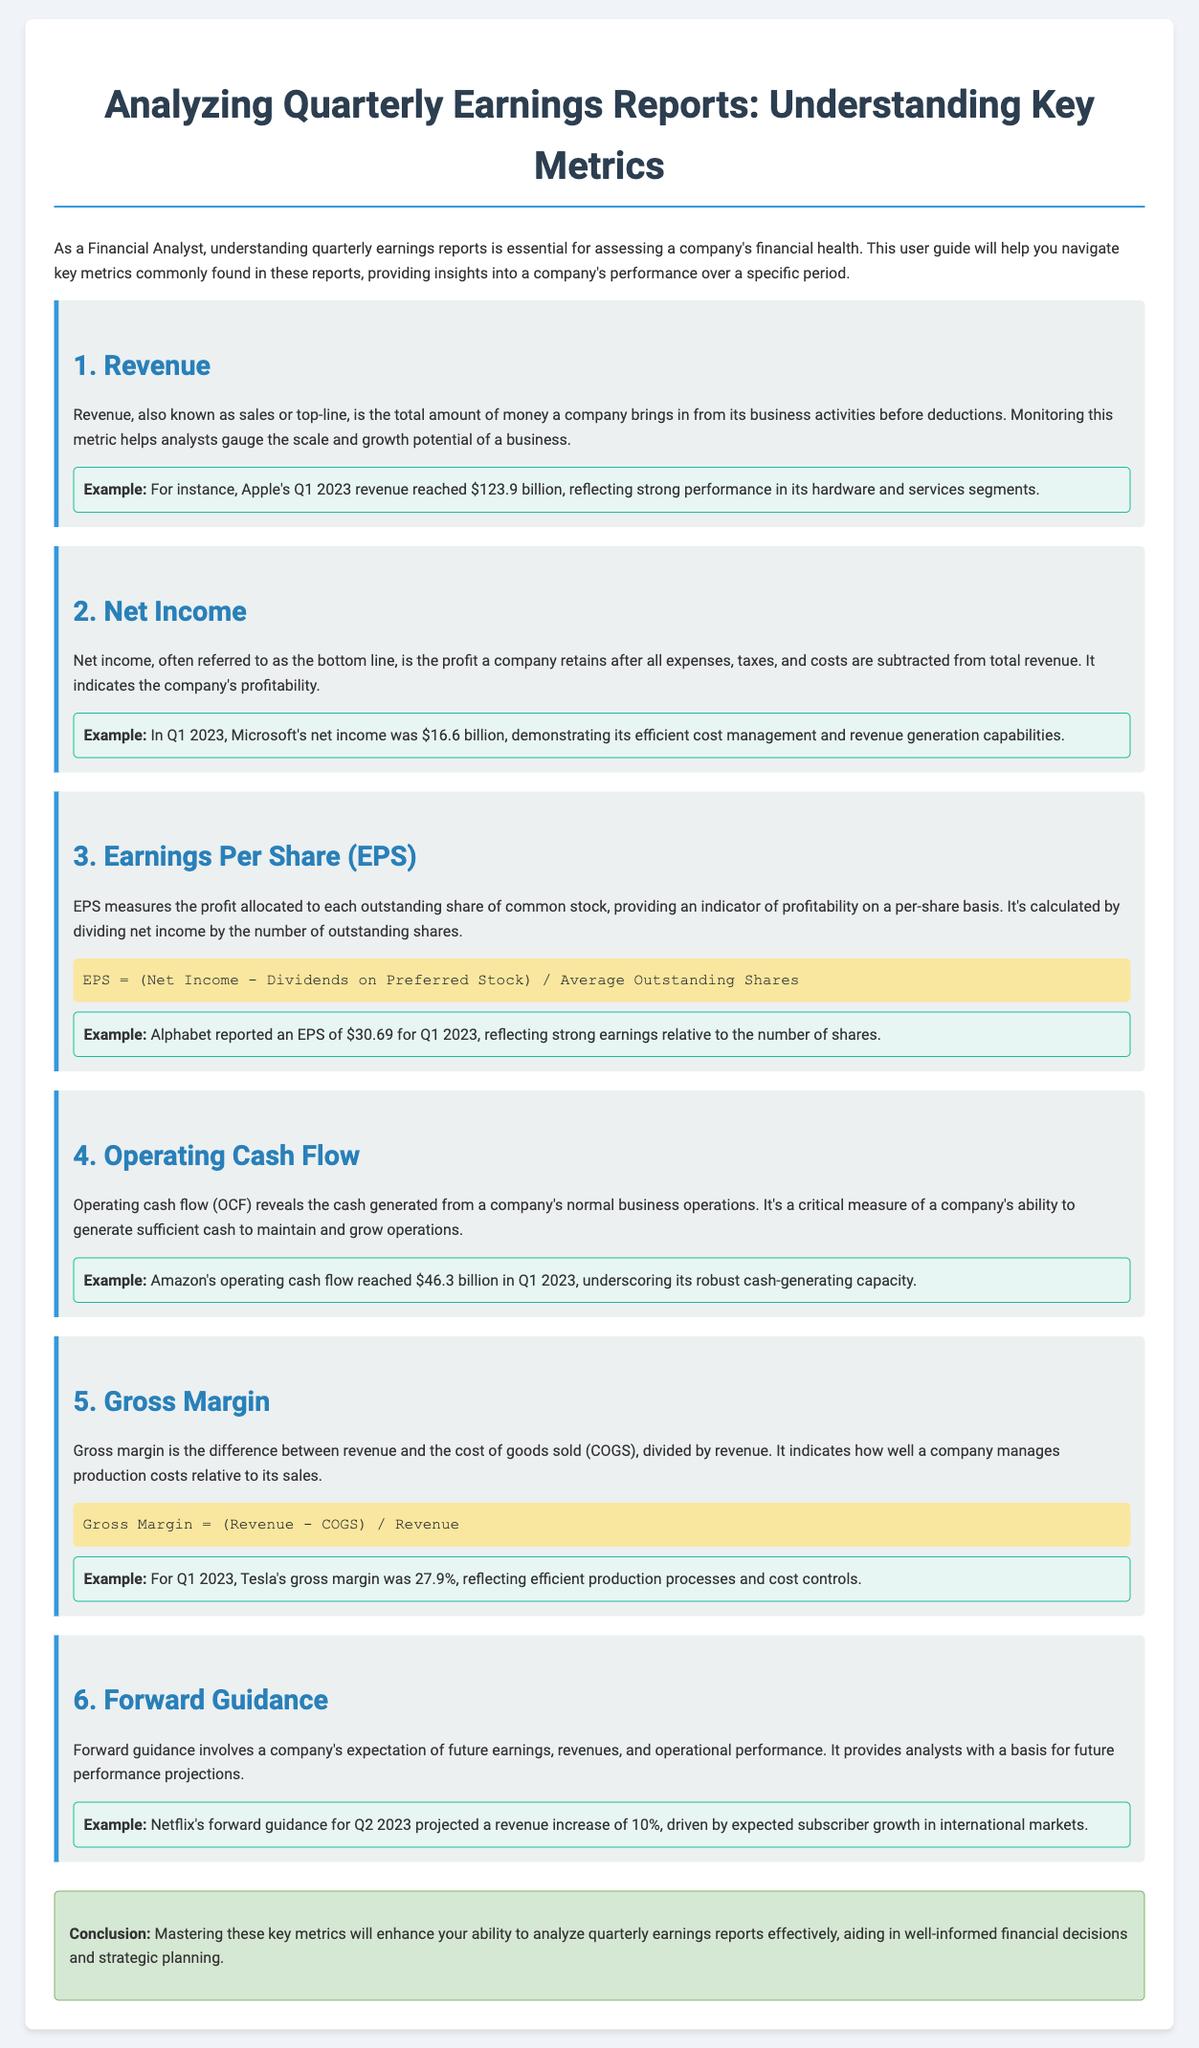what is the total revenue for Apple in Q1 2023? The document specifies that Apple's Q1 2023 revenue reached $123.9 billion.
Answer: $123.9 billion what was Microsoft's net income in Q1 2023? The net income reported for Microsoft in Q1 2023 is given as $16.6 billion.
Answer: $16.6 billion how is Earnings Per Share (EPS) calculated? The formula for calculating EPS is provided in the document: (Net Income - Dividends on Preferred Stock) / Average Outstanding Shares.
Answer: (Net Income - Dividends on Preferred Stock) / Average Outstanding Shares what is Amazon's operating cash flow for Q1 2023? According to the document, Amazon's operating cash flow for Q1 2023 was $46.3 billion.
Answer: $46.3 billion what is the gross margin percentage for Tesla in Q1 2023? The document states that Tesla's gross margin for Q1 2023 was 27.9%.
Answer: 27.9% what does forward guidance indicate? Forward guidance encompasses a company's expectations of future earnings, revenues, and operational performance.
Answer: Future earnings expectations why is revenue a crucial metric? Revenue helps analysts gauge the scale and growth potential of a business.
Answer: Growth potential what type of document is this? This document serves as a user guide focused on analyzing quarterly earnings reports.
Answer: User guide what is the primary purpose of this user guide? The guide aims to help analysts navigate key metrics in quarterly earnings reports to assess a company's financial health.
Answer: Assess financial health 